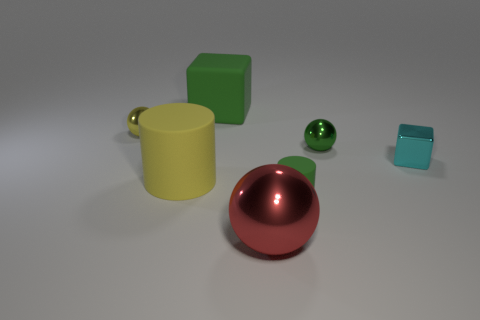Is the number of big green matte things greater than the number of big gray metal things?
Your answer should be compact. Yes. There is a green metal thing that is right of the big cylinder; does it have the same shape as the small green matte thing?
Provide a succinct answer. No. How many things are both to the left of the small green cylinder and in front of the large yellow matte object?
Your response must be concise. 1. What number of yellow rubber objects are the same shape as the large red shiny object?
Keep it short and to the point. 0. The big rubber block behind the matte cylinder that is on the right side of the yellow rubber thing is what color?
Your answer should be compact. Green. Is the shape of the large green object the same as the shiny object left of the big yellow object?
Provide a succinct answer. No. What is the tiny sphere that is on the right side of the tiny thing that is on the left side of the green matte object on the right side of the large green rubber thing made of?
Make the answer very short. Metal. Is there a green matte object of the same size as the red object?
Offer a very short reply. Yes. The other cylinder that is the same material as the tiny cylinder is what size?
Give a very brief answer. Large. The big yellow object has what shape?
Provide a succinct answer. Cylinder. 